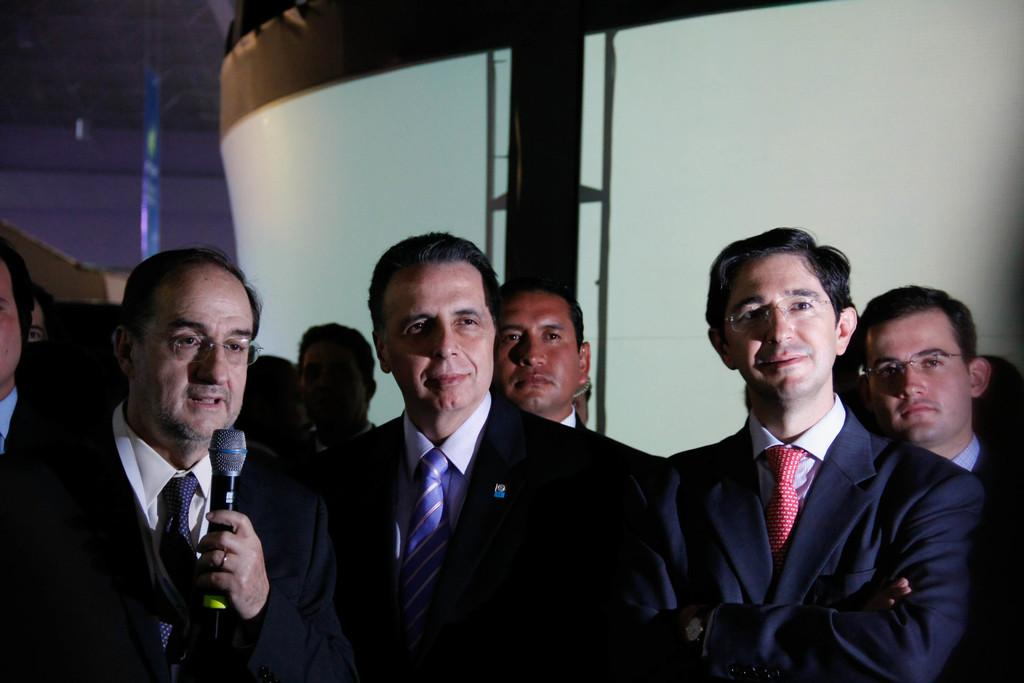What is the primary activity of the men in the image? The men in the image are standing. Can you describe what one of the men is holding? One man is holding a mic. What type of loaf is being prepared on the stove in the image? There is no loaf or stove present in the image; it features men standing, with one holding a mic. 